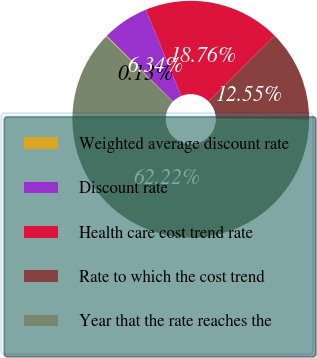Convert chart. <chart><loc_0><loc_0><loc_500><loc_500><pie_chart><fcel>Weighted average discount rate<fcel>Discount rate<fcel>Health care cost trend rate<fcel>Rate to which the cost trend<fcel>Year that the rate reaches the<nl><fcel>0.13%<fcel>6.34%<fcel>18.76%<fcel>12.55%<fcel>62.23%<nl></chart> 